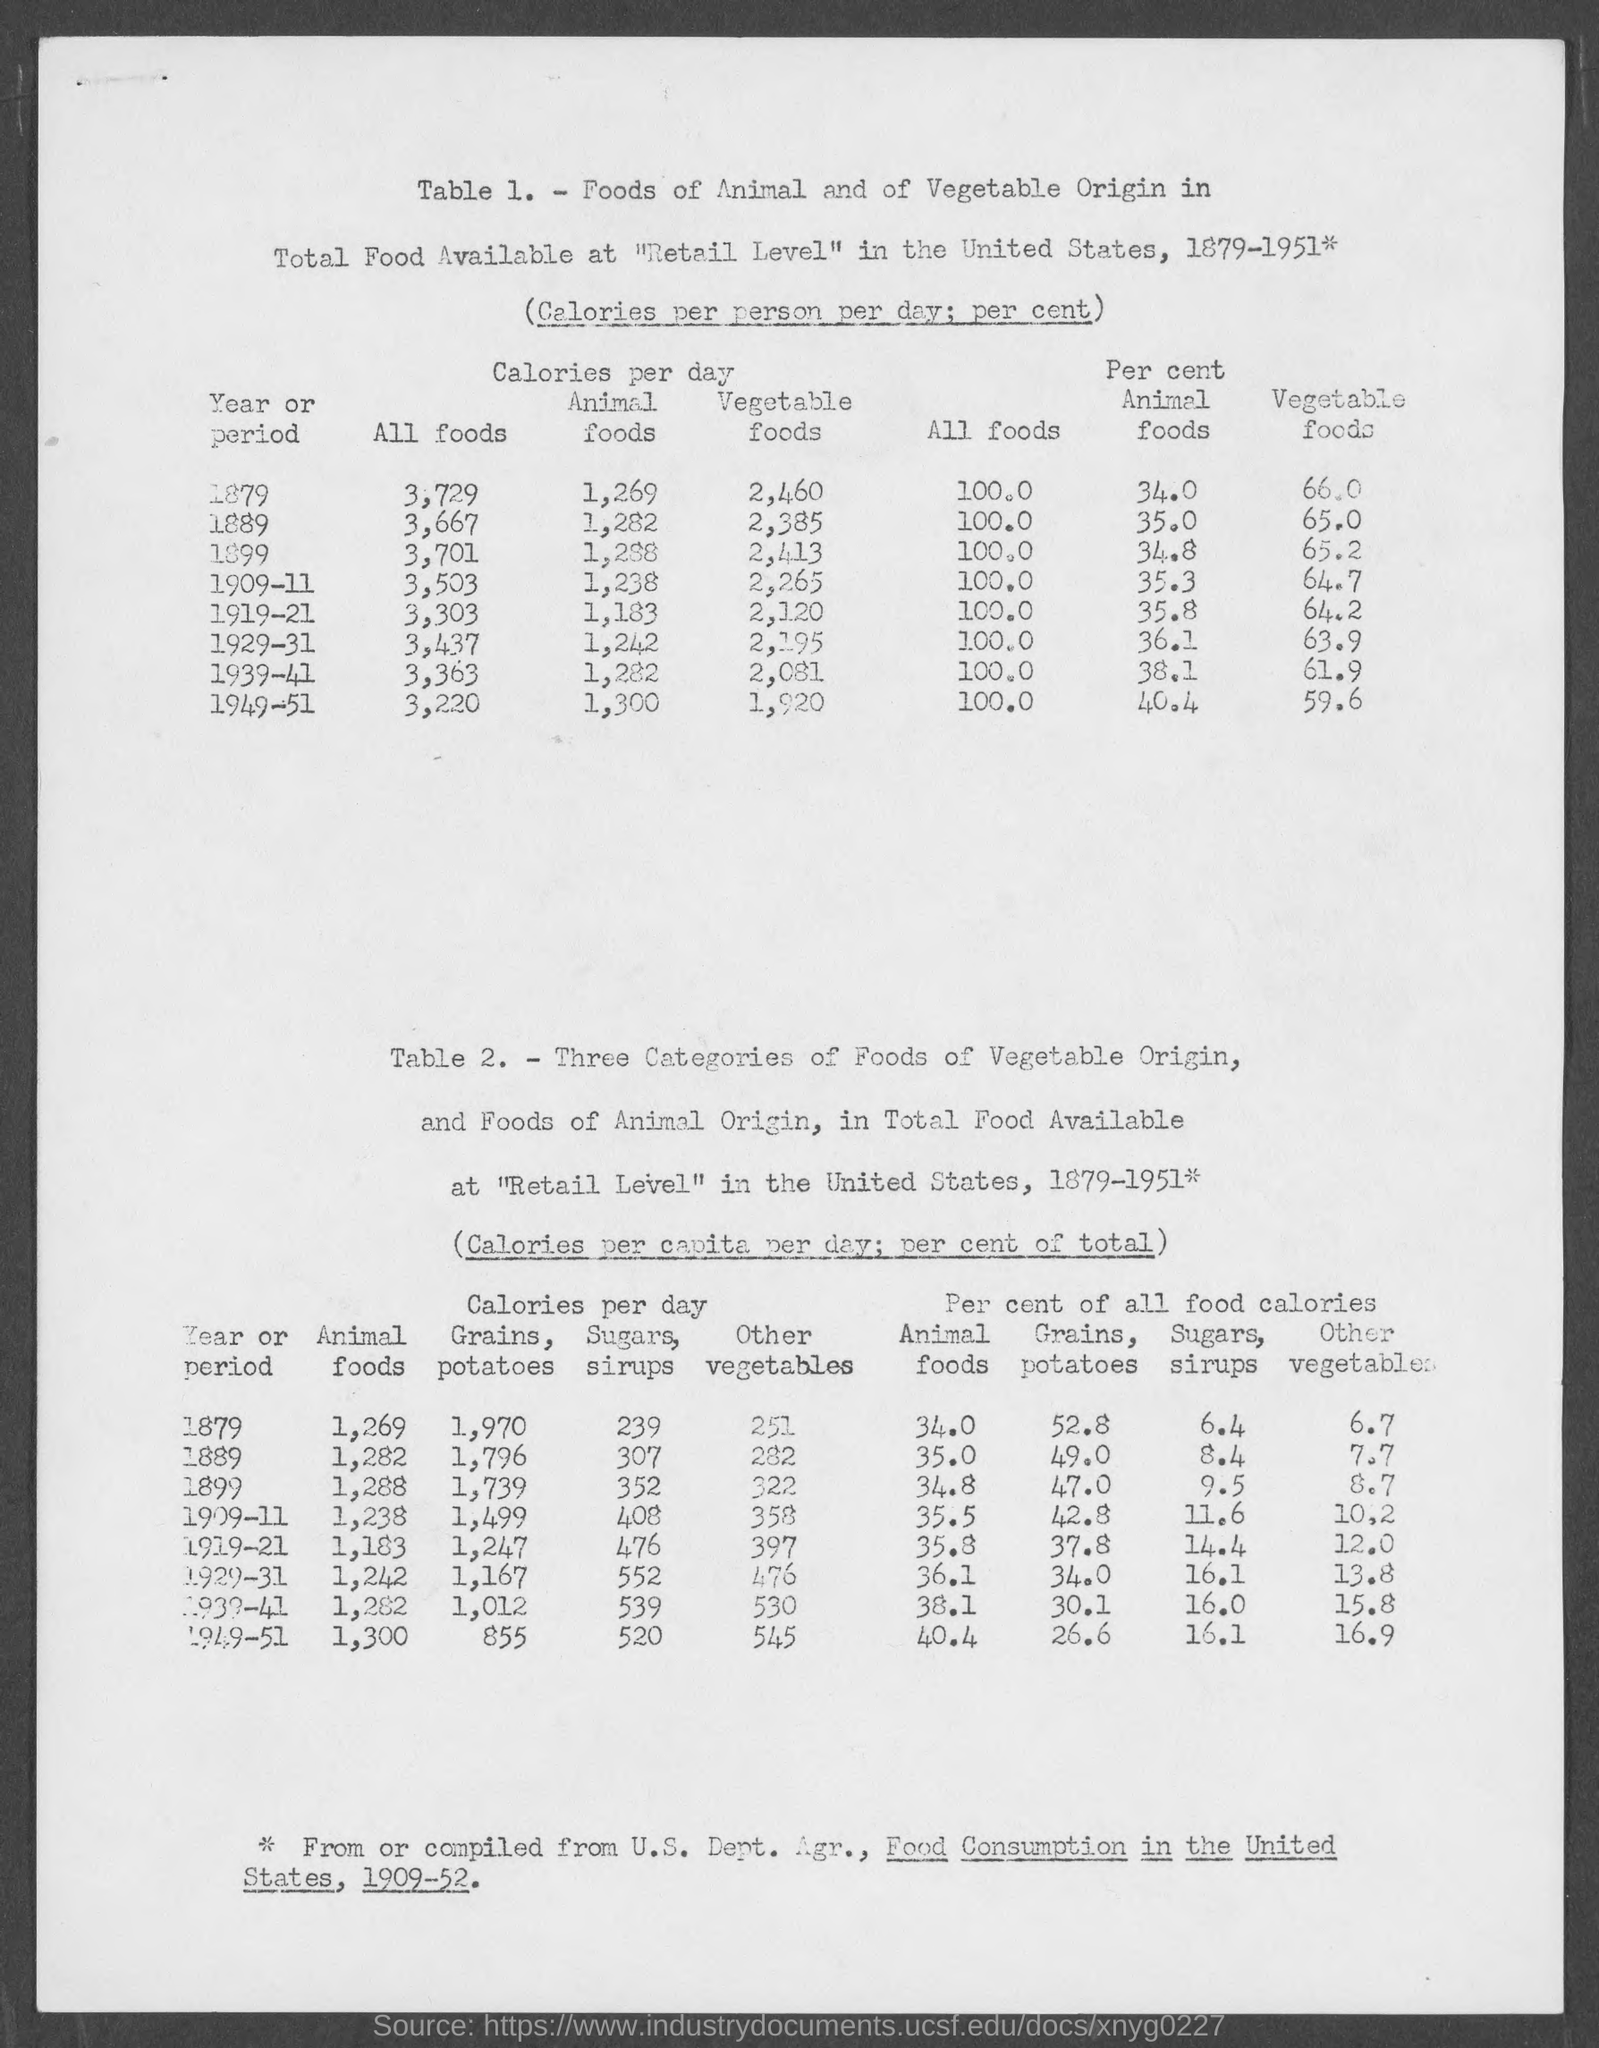Identify some key points in this picture. In the year 1879, the total amount of calories present in all foods was 3,729. In 1889, the amount of calories present in animal foods was approximately 35 calories per cent. The amount of calories per day present in animal foods in the year 1879 was 1,269. The amount of calories per day present in all foods in the year 1889 was 3,667. The amount of calories per day present in vegetable foods in the year 1889 was approximately 2,385 calories per day. 